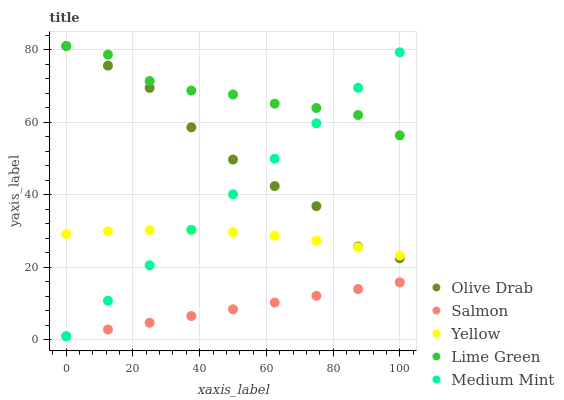Does Salmon have the minimum area under the curve?
Answer yes or no. Yes. Does Lime Green have the maximum area under the curve?
Answer yes or no. Yes. Does Lime Green have the minimum area under the curve?
Answer yes or no. No. Does Salmon have the maximum area under the curve?
Answer yes or no. No. Is Salmon the smoothest?
Answer yes or no. Yes. Is Olive Drab the roughest?
Answer yes or no. Yes. Is Lime Green the smoothest?
Answer yes or no. No. Is Lime Green the roughest?
Answer yes or no. No. Does Medium Mint have the lowest value?
Answer yes or no. Yes. Does Lime Green have the lowest value?
Answer yes or no. No. Does Olive Drab have the highest value?
Answer yes or no. Yes. Does Salmon have the highest value?
Answer yes or no. No. Is Salmon less than Olive Drab?
Answer yes or no. Yes. Is Olive Drab greater than Salmon?
Answer yes or no. Yes. Does Medium Mint intersect Yellow?
Answer yes or no. Yes. Is Medium Mint less than Yellow?
Answer yes or no. No. Is Medium Mint greater than Yellow?
Answer yes or no. No. Does Salmon intersect Olive Drab?
Answer yes or no. No. 